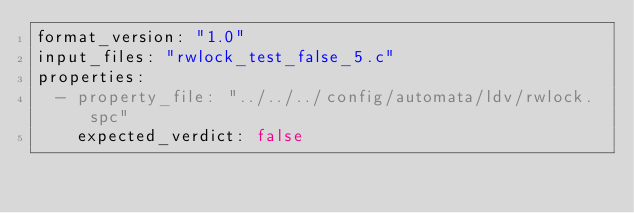<code> <loc_0><loc_0><loc_500><loc_500><_YAML_>format_version: "1.0"
input_files: "rwlock_test_false_5.c"
properties:
  - property_file: "../../../config/automata/ldv/rwlock.spc"
    expected_verdict: false

</code> 